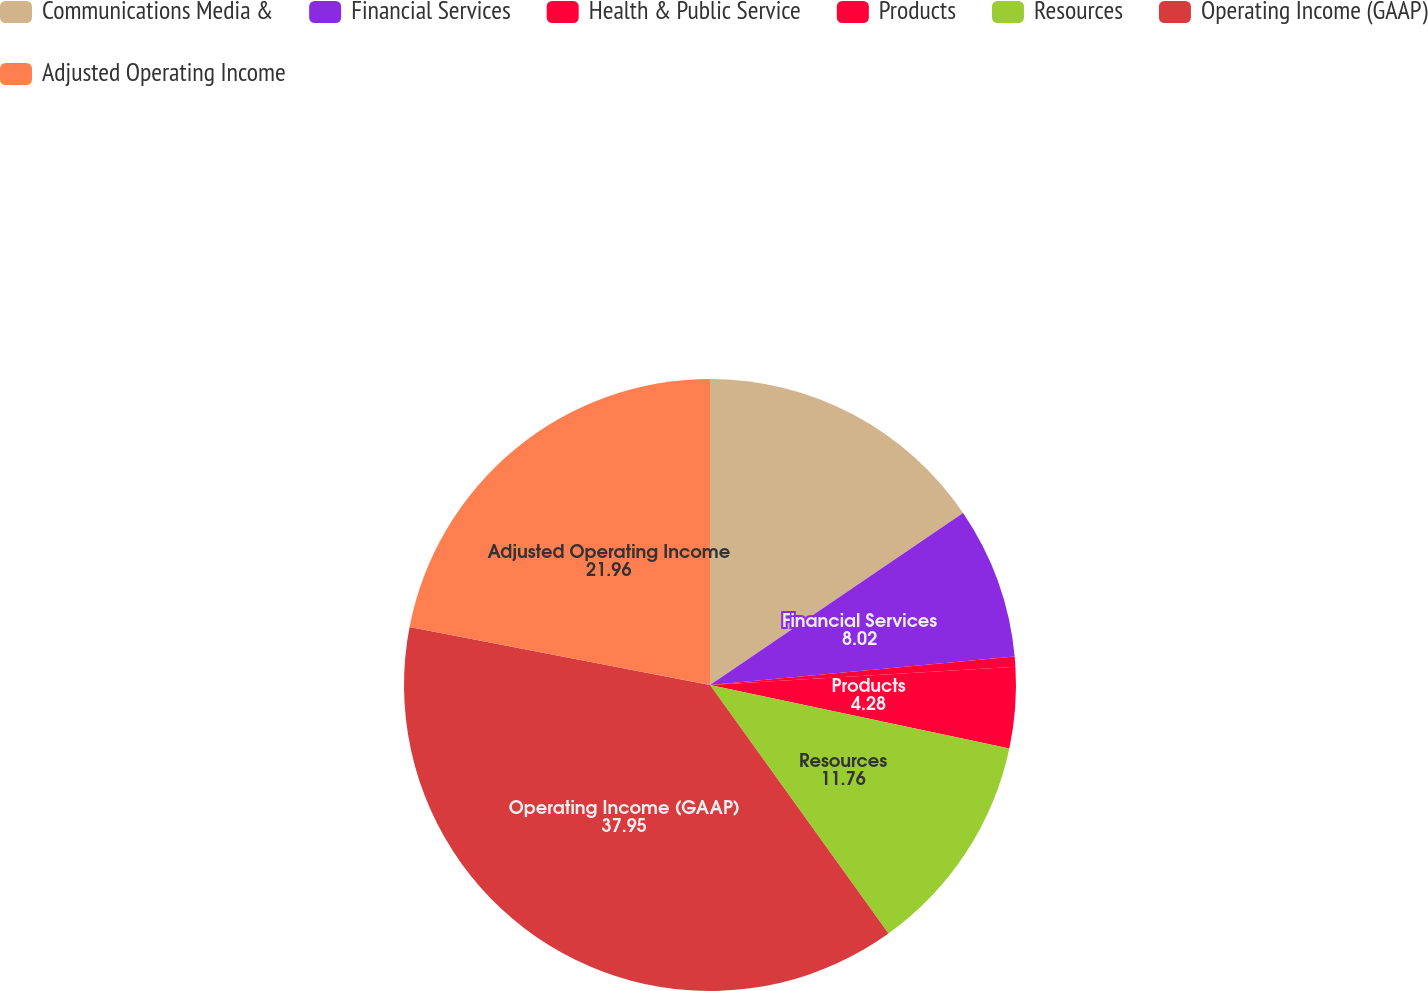Convert chart to OTSL. <chart><loc_0><loc_0><loc_500><loc_500><pie_chart><fcel>Communications Media &<fcel>Financial Services<fcel>Health & Public Service<fcel>Products<fcel>Resources<fcel>Operating Income (GAAP)<fcel>Adjusted Operating Income<nl><fcel>15.5%<fcel>8.02%<fcel>0.53%<fcel>4.28%<fcel>11.76%<fcel>37.95%<fcel>21.96%<nl></chart> 